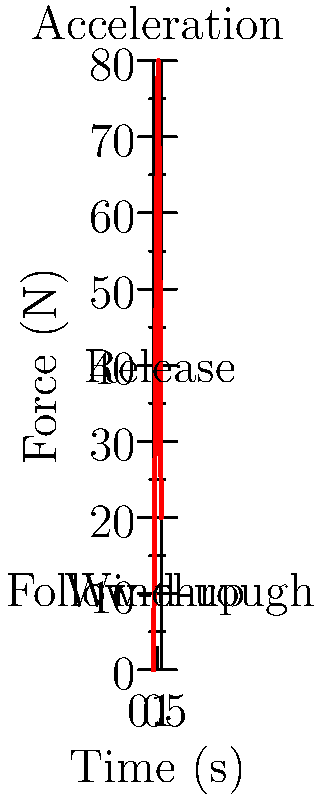The graph shows the force distribution during a softball player's throwing motion. At which phase of the throw does the player exert the maximum force? To determine the phase of maximum force exertion, let's analyze the graph step-by-step:

1. The x-axis represents time (in seconds), and the y-axis represents force (in Newtons).
2. The graph is divided into four main phases: wind-up, acceleration, release, and follow-through.
3. Wind-up (0-0.2s): Force increases from 0 to about 30N.
4. Acceleration (0.2-0.6s): Force increases rapidly from 30N to the peak of 80N.
5. Release (0.6-0.8s): Force decreases from 80N to about 60N.
6. Follow-through (0.8-1.0s): Force continues to decrease from 60N to 20N.

The maximum force of 80N occurs during the acceleration phase, specifically at around 0.6 seconds into the throw.
Answer: Acceleration phase 